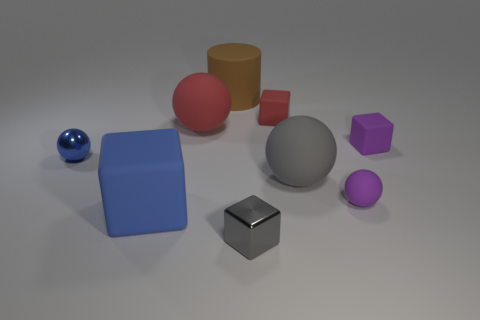Subtract all gray balls. How many balls are left? 3 Subtract all red spheres. How many spheres are left? 3 Add 1 tiny blue things. How many objects exist? 10 Subtract all green balls. Subtract all gray cylinders. How many balls are left? 4 Subtract all balls. How many objects are left? 5 Subtract all tiny cubes. Subtract all purple balls. How many objects are left? 5 Add 7 brown things. How many brown things are left? 8 Add 9 red spheres. How many red spheres exist? 10 Subtract 0 green blocks. How many objects are left? 9 